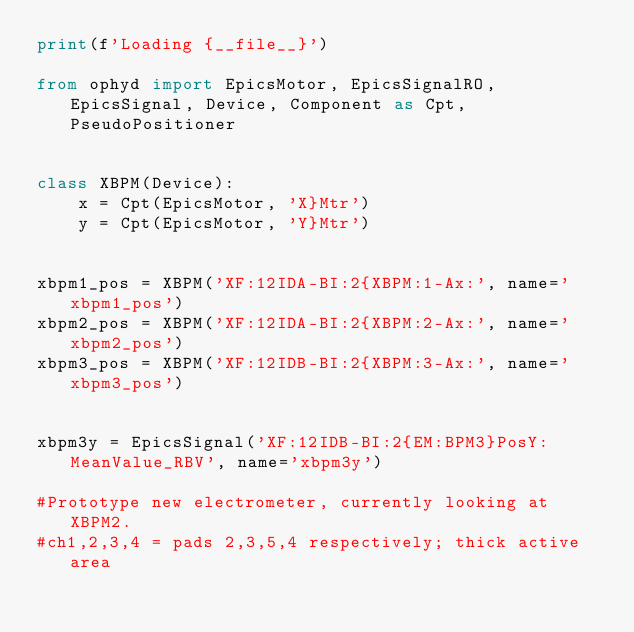<code> <loc_0><loc_0><loc_500><loc_500><_Python_>print(f'Loading {__file__}')

from ophyd import EpicsMotor, EpicsSignalRO, EpicsSignal, Device, Component as Cpt, PseudoPositioner


class XBPM(Device):
    x = Cpt(EpicsMotor, 'X}Mtr')
    y = Cpt(EpicsMotor, 'Y}Mtr')


xbpm1_pos = XBPM('XF:12IDA-BI:2{XBPM:1-Ax:', name='xbpm1_pos')
xbpm2_pos = XBPM('XF:12IDA-BI:2{XBPM:2-Ax:', name='xbpm2_pos')
xbpm3_pos = XBPM('XF:12IDB-BI:2{XBPM:3-Ax:', name='xbpm3_pos')


xbpm3y = EpicsSignal('XF:12IDB-BI:2{EM:BPM3}PosY:MeanValue_RBV', name='xbpm3y')

#Prototype new electrometer, currently looking at XBPM2.
#ch1,2,3,4 = pads 2,3,5,4 respectively; thick active area






</code> 